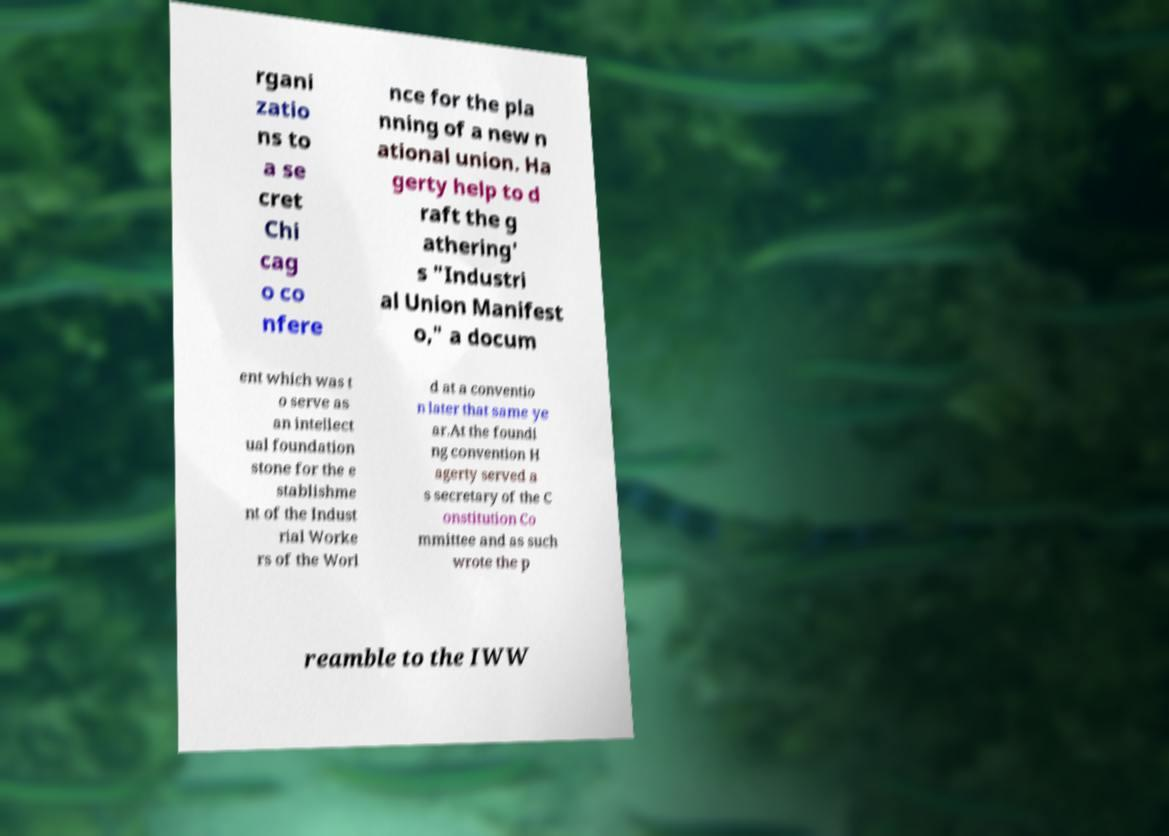Can you accurately transcribe the text from the provided image for me? rgani zatio ns to a se cret Chi cag o co nfere nce for the pla nning of a new n ational union. Ha gerty help to d raft the g athering' s "Industri al Union Manifest o," a docum ent which was t o serve as an intellect ual foundation stone for the e stablishme nt of the Indust rial Worke rs of the Worl d at a conventio n later that same ye ar.At the foundi ng convention H agerty served a s secretary of the C onstitution Co mmittee and as such wrote the p reamble to the IWW 